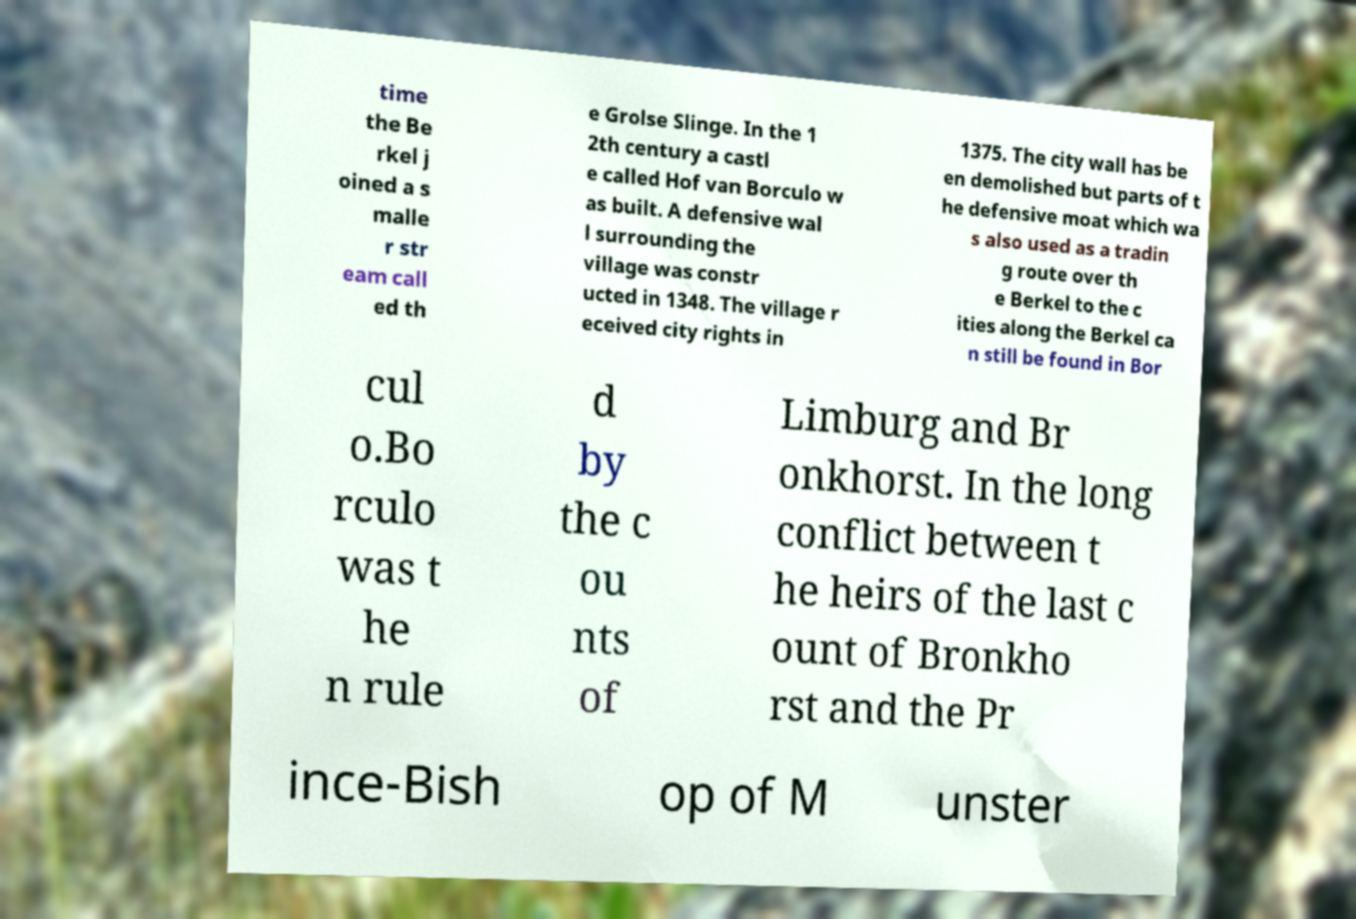Could you assist in decoding the text presented in this image and type it out clearly? time the Be rkel j oined a s malle r str eam call ed th e Grolse Slinge. In the 1 2th century a castl e called Hof van Borculo w as built. A defensive wal l surrounding the village was constr ucted in 1348. The village r eceived city rights in 1375. The city wall has be en demolished but parts of t he defensive moat which wa s also used as a tradin g route over th e Berkel to the c ities along the Berkel ca n still be found in Bor cul o.Bo rculo was t he n rule d by the c ou nts of Limburg and Br onkhorst. In the long conflict between t he heirs of the last c ount of Bronkho rst and the Pr ince-Bish op of M unster 